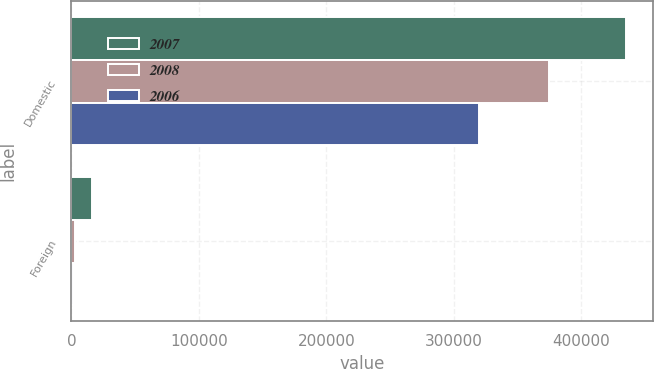Convert chart to OTSL. <chart><loc_0><loc_0><loc_500><loc_500><stacked_bar_chart><ecel><fcel>Domestic<fcel>Foreign<nl><fcel>2007<fcel>434816<fcel>16351<nl><fcel>2008<fcel>374920<fcel>2979<nl><fcel>2006<fcel>319494<fcel>1535<nl></chart> 